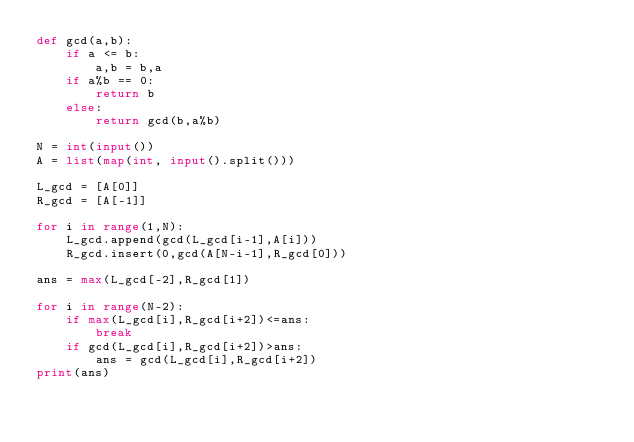<code> <loc_0><loc_0><loc_500><loc_500><_Python_>def gcd(a,b):
    if a <= b:
        a,b = b,a
    if a%b == 0:
        return b
    else:
        return gcd(b,a%b)

N = int(input())
A = list(map(int, input().split()))

L_gcd = [A[0]]
R_gcd = [A[-1]]

for i in range(1,N):
    L_gcd.append(gcd(L_gcd[i-1],A[i]))
    R_gcd.insert(0,gcd(A[N-i-1],R_gcd[0]))

ans = max(L_gcd[-2],R_gcd[1])

for i in range(N-2):
    if max(L_gcd[i],R_gcd[i+2])<=ans:
        break
    if gcd(L_gcd[i],R_gcd[i+2])>ans:
        ans = gcd(L_gcd[i],R_gcd[i+2])
print(ans)</code> 